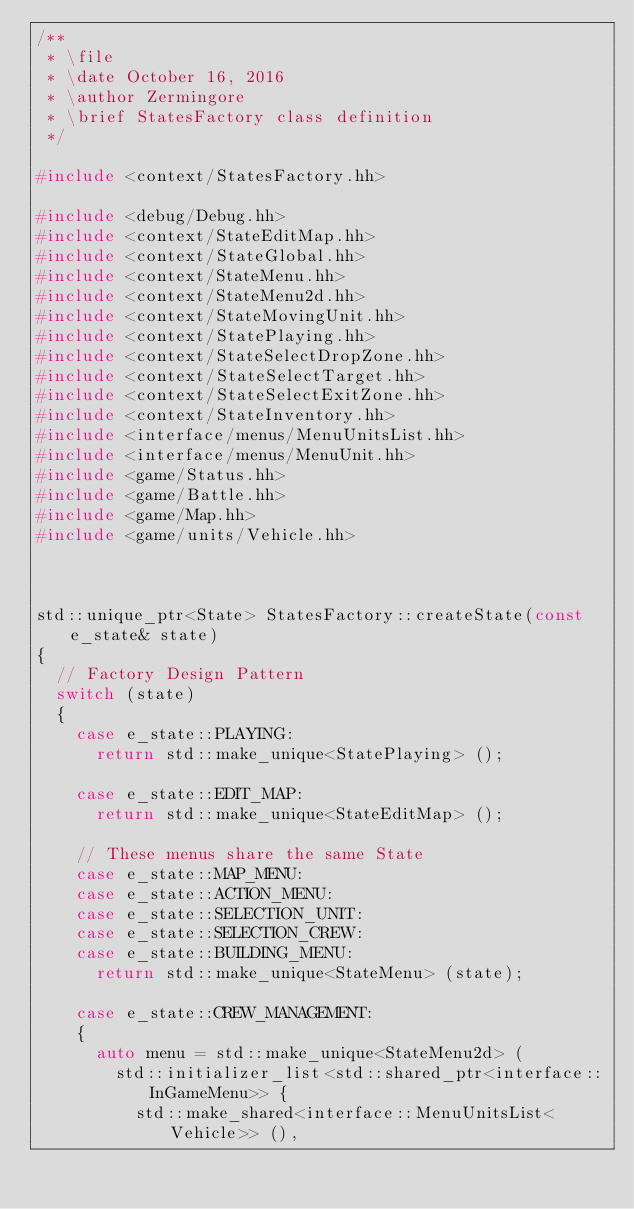<code> <loc_0><loc_0><loc_500><loc_500><_C++_>/**
 * \file
 * \date October 16, 2016
 * \author Zermingore
 * \brief StatesFactory class definition
 */

#include <context/StatesFactory.hh>

#include <debug/Debug.hh>
#include <context/StateEditMap.hh>
#include <context/StateGlobal.hh>
#include <context/StateMenu.hh>
#include <context/StateMenu2d.hh>
#include <context/StateMovingUnit.hh>
#include <context/StatePlaying.hh>
#include <context/StateSelectDropZone.hh>
#include <context/StateSelectTarget.hh>
#include <context/StateSelectExitZone.hh>
#include <context/StateInventory.hh>
#include <interface/menus/MenuUnitsList.hh>
#include <interface/menus/MenuUnit.hh>
#include <game/Status.hh>
#include <game/Battle.hh>
#include <game/Map.hh>
#include <game/units/Vehicle.hh>



std::unique_ptr<State> StatesFactory::createState(const e_state& state)
{
  // Factory Design Pattern
  switch (state)
  {
    case e_state::PLAYING:
      return std::make_unique<StatePlaying> ();

    case e_state::EDIT_MAP:
      return std::make_unique<StateEditMap> ();

    // These menus share the same State
    case e_state::MAP_MENU:
    case e_state::ACTION_MENU:
    case e_state::SELECTION_UNIT:
    case e_state::SELECTION_CREW:
    case e_state::BUILDING_MENU:
      return std::make_unique<StateMenu> (state);

    case e_state::CREW_MANAGEMENT:
    {
      auto menu = std::make_unique<StateMenu2d> (
        std::initializer_list<std::shared_ptr<interface::InGameMenu>> {
          std::make_shared<interface::MenuUnitsList<Vehicle>> (),</code> 